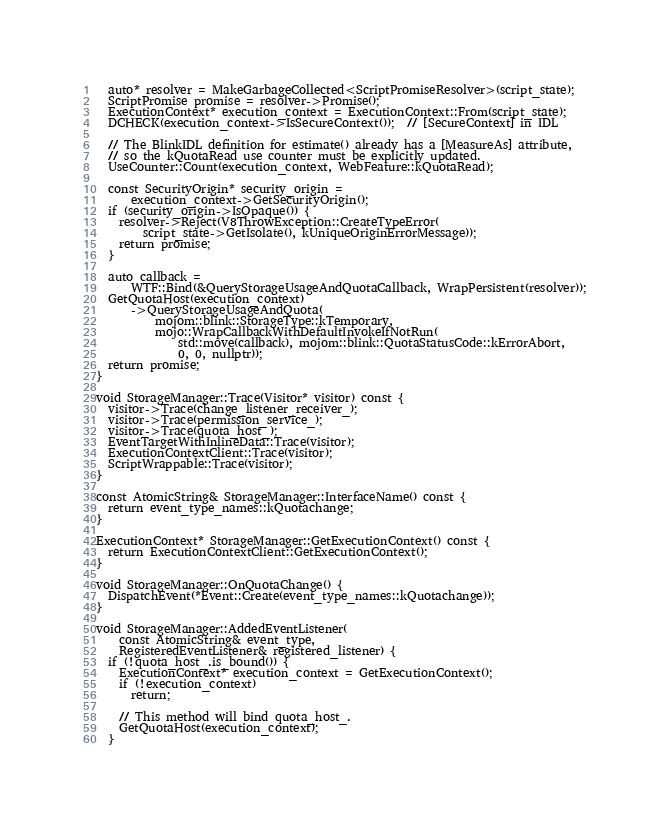<code> <loc_0><loc_0><loc_500><loc_500><_C++_>  auto* resolver = MakeGarbageCollected<ScriptPromiseResolver>(script_state);
  ScriptPromise promise = resolver->Promise();
  ExecutionContext* execution_context = ExecutionContext::From(script_state);
  DCHECK(execution_context->IsSecureContext());  // [SecureContext] in IDL

  // The BlinkIDL definition for estimate() already has a [MeasureAs] attribute,
  // so the kQuotaRead use counter must be explicitly updated.
  UseCounter::Count(execution_context, WebFeature::kQuotaRead);

  const SecurityOrigin* security_origin =
      execution_context->GetSecurityOrigin();
  if (security_origin->IsOpaque()) {
    resolver->Reject(V8ThrowException::CreateTypeError(
        script_state->GetIsolate(), kUniqueOriginErrorMessage));
    return promise;
  }

  auto callback =
      WTF::Bind(&QueryStorageUsageAndQuotaCallback, WrapPersistent(resolver));
  GetQuotaHost(execution_context)
      ->QueryStorageUsageAndQuota(
          mojom::blink::StorageType::kTemporary,
          mojo::WrapCallbackWithDefaultInvokeIfNotRun(
              std::move(callback), mojom::blink::QuotaStatusCode::kErrorAbort,
              0, 0, nullptr));
  return promise;
}

void StorageManager::Trace(Visitor* visitor) const {
  visitor->Trace(change_listener_receiver_);
  visitor->Trace(permission_service_);
  visitor->Trace(quota_host_);
  EventTargetWithInlineData::Trace(visitor);
  ExecutionContextClient::Trace(visitor);
  ScriptWrappable::Trace(visitor);
}

const AtomicString& StorageManager::InterfaceName() const {
  return event_type_names::kQuotachange;
}

ExecutionContext* StorageManager::GetExecutionContext() const {
  return ExecutionContextClient::GetExecutionContext();
}

void StorageManager::OnQuotaChange() {
  DispatchEvent(*Event::Create(event_type_names::kQuotachange));
}

void StorageManager::AddedEventListener(
    const AtomicString& event_type,
    RegisteredEventListener& registered_listener) {
  if (!quota_host_.is_bound()) {
    ExecutionContext* execution_context = GetExecutionContext();
    if (!execution_context)
      return;

    // This method will bind quota_host_.
    GetQuotaHost(execution_context);
  }</code> 